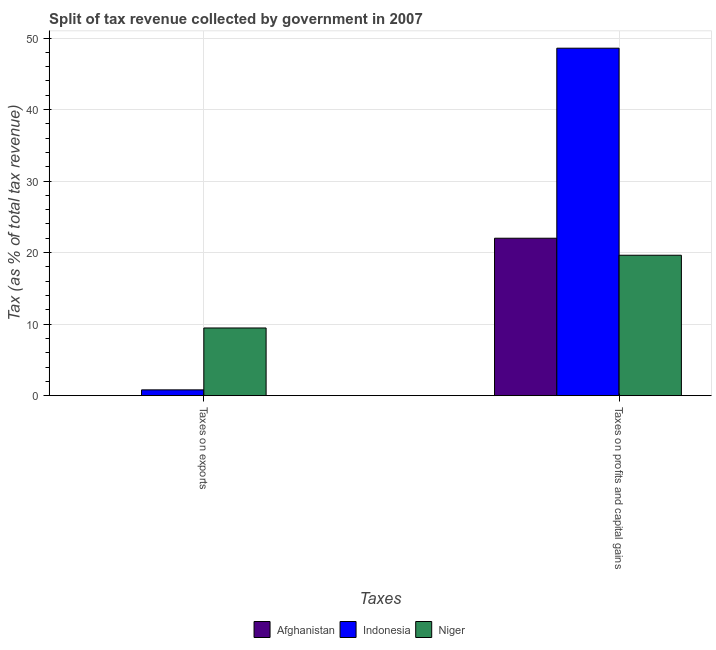Are the number of bars on each tick of the X-axis equal?
Keep it short and to the point. Yes. What is the label of the 2nd group of bars from the left?
Your answer should be very brief. Taxes on profits and capital gains. What is the percentage of revenue obtained from taxes on profits and capital gains in Afghanistan?
Your answer should be compact. 22.01. Across all countries, what is the maximum percentage of revenue obtained from taxes on profits and capital gains?
Provide a succinct answer. 48.58. Across all countries, what is the minimum percentage of revenue obtained from taxes on profits and capital gains?
Your response must be concise. 19.63. In which country was the percentage of revenue obtained from taxes on exports maximum?
Provide a short and direct response. Niger. In which country was the percentage of revenue obtained from taxes on profits and capital gains minimum?
Provide a succinct answer. Niger. What is the total percentage of revenue obtained from taxes on exports in the graph?
Keep it short and to the point. 10.28. What is the difference between the percentage of revenue obtained from taxes on exports in Afghanistan and that in Niger?
Offer a terse response. -9.45. What is the difference between the percentage of revenue obtained from taxes on profits and capital gains in Indonesia and the percentage of revenue obtained from taxes on exports in Niger?
Provide a short and direct response. 39.12. What is the average percentage of revenue obtained from taxes on profits and capital gains per country?
Offer a terse response. 30.07. What is the difference between the percentage of revenue obtained from taxes on profits and capital gains and percentage of revenue obtained from taxes on exports in Indonesia?
Keep it short and to the point. 47.77. In how many countries, is the percentage of revenue obtained from taxes on profits and capital gains greater than 16 %?
Provide a short and direct response. 3. What is the ratio of the percentage of revenue obtained from taxes on profits and capital gains in Indonesia to that in Afghanistan?
Provide a succinct answer. 2.21. Is the percentage of revenue obtained from taxes on profits and capital gains in Niger less than that in Indonesia?
Make the answer very short. Yes. In how many countries, is the percentage of revenue obtained from taxes on exports greater than the average percentage of revenue obtained from taxes on exports taken over all countries?
Provide a short and direct response. 1. What does the 2nd bar from the left in Taxes on profits and capital gains represents?
Your answer should be very brief. Indonesia. What does the 3rd bar from the right in Taxes on exports represents?
Make the answer very short. Afghanistan. What is the difference between two consecutive major ticks on the Y-axis?
Ensure brevity in your answer.  10. Are the values on the major ticks of Y-axis written in scientific E-notation?
Your response must be concise. No. Where does the legend appear in the graph?
Ensure brevity in your answer.  Bottom center. How are the legend labels stacked?
Your answer should be very brief. Horizontal. What is the title of the graph?
Give a very brief answer. Split of tax revenue collected by government in 2007. Does "Swaziland" appear as one of the legend labels in the graph?
Your response must be concise. No. What is the label or title of the X-axis?
Provide a short and direct response. Taxes. What is the label or title of the Y-axis?
Your answer should be very brief. Tax (as % of total tax revenue). What is the Tax (as % of total tax revenue) in Afghanistan in Taxes on exports?
Offer a very short reply. 0.01. What is the Tax (as % of total tax revenue) in Indonesia in Taxes on exports?
Provide a succinct answer. 0.81. What is the Tax (as % of total tax revenue) of Niger in Taxes on exports?
Provide a short and direct response. 9.46. What is the Tax (as % of total tax revenue) of Afghanistan in Taxes on profits and capital gains?
Provide a succinct answer. 22.01. What is the Tax (as % of total tax revenue) of Indonesia in Taxes on profits and capital gains?
Your answer should be compact. 48.58. What is the Tax (as % of total tax revenue) of Niger in Taxes on profits and capital gains?
Offer a very short reply. 19.63. Across all Taxes, what is the maximum Tax (as % of total tax revenue) in Afghanistan?
Give a very brief answer. 22.01. Across all Taxes, what is the maximum Tax (as % of total tax revenue) in Indonesia?
Make the answer very short. 48.58. Across all Taxes, what is the maximum Tax (as % of total tax revenue) in Niger?
Keep it short and to the point. 19.63. Across all Taxes, what is the minimum Tax (as % of total tax revenue) of Afghanistan?
Your answer should be compact. 0.01. Across all Taxes, what is the minimum Tax (as % of total tax revenue) of Indonesia?
Make the answer very short. 0.81. Across all Taxes, what is the minimum Tax (as % of total tax revenue) of Niger?
Your answer should be compact. 9.46. What is the total Tax (as % of total tax revenue) in Afghanistan in the graph?
Keep it short and to the point. 22.02. What is the total Tax (as % of total tax revenue) in Indonesia in the graph?
Make the answer very short. 49.39. What is the total Tax (as % of total tax revenue) in Niger in the graph?
Make the answer very short. 29.09. What is the difference between the Tax (as % of total tax revenue) of Afghanistan in Taxes on exports and that in Taxes on profits and capital gains?
Provide a succinct answer. -22. What is the difference between the Tax (as % of total tax revenue) in Indonesia in Taxes on exports and that in Taxes on profits and capital gains?
Offer a terse response. -47.77. What is the difference between the Tax (as % of total tax revenue) in Niger in Taxes on exports and that in Taxes on profits and capital gains?
Your answer should be compact. -10.17. What is the difference between the Tax (as % of total tax revenue) of Afghanistan in Taxes on exports and the Tax (as % of total tax revenue) of Indonesia in Taxes on profits and capital gains?
Make the answer very short. -48.56. What is the difference between the Tax (as % of total tax revenue) of Afghanistan in Taxes on exports and the Tax (as % of total tax revenue) of Niger in Taxes on profits and capital gains?
Your answer should be compact. -19.62. What is the difference between the Tax (as % of total tax revenue) of Indonesia in Taxes on exports and the Tax (as % of total tax revenue) of Niger in Taxes on profits and capital gains?
Offer a terse response. -18.82. What is the average Tax (as % of total tax revenue) in Afghanistan per Taxes?
Ensure brevity in your answer.  11.01. What is the average Tax (as % of total tax revenue) in Indonesia per Taxes?
Offer a very short reply. 24.69. What is the average Tax (as % of total tax revenue) of Niger per Taxes?
Offer a very short reply. 14.55. What is the difference between the Tax (as % of total tax revenue) of Afghanistan and Tax (as % of total tax revenue) of Indonesia in Taxes on exports?
Make the answer very short. -0.79. What is the difference between the Tax (as % of total tax revenue) in Afghanistan and Tax (as % of total tax revenue) in Niger in Taxes on exports?
Your response must be concise. -9.45. What is the difference between the Tax (as % of total tax revenue) of Indonesia and Tax (as % of total tax revenue) of Niger in Taxes on exports?
Give a very brief answer. -8.66. What is the difference between the Tax (as % of total tax revenue) in Afghanistan and Tax (as % of total tax revenue) in Indonesia in Taxes on profits and capital gains?
Offer a very short reply. -26.57. What is the difference between the Tax (as % of total tax revenue) in Afghanistan and Tax (as % of total tax revenue) in Niger in Taxes on profits and capital gains?
Make the answer very short. 2.38. What is the difference between the Tax (as % of total tax revenue) in Indonesia and Tax (as % of total tax revenue) in Niger in Taxes on profits and capital gains?
Offer a terse response. 28.95. What is the ratio of the Tax (as % of total tax revenue) in Afghanistan in Taxes on exports to that in Taxes on profits and capital gains?
Your answer should be compact. 0. What is the ratio of the Tax (as % of total tax revenue) of Indonesia in Taxes on exports to that in Taxes on profits and capital gains?
Give a very brief answer. 0.02. What is the ratio of the Tax (as % of total tax revenue) in Niger in Taxes on exports to that in Taxes on profits and capital gains?
Offer a terse response. 0.48. What is the difference between the highest and the second highest Tax (as % of total tax revenue) in Afghanistan?
Make the answer very short. 22. What is the difference between the highest and the second highest Tax (as % of total tax revenue) in Indonesia?
Your response must be concise. 47.77. What is the difference between the highest and the second highest Tax (as % of total tax revenue) of Niger?
Provide a succinct answer. 10.17. What is the difference between the highest and the lowest Tax (as % of total tax revenue) in Afghanistan?
Your response must be concise. 22. What is the difference between the highest and the lowest Tax (as % of total tax revenue) of Indonesia?
Ensure brevity in your answer.  47.77. What is the difference between the highest and the lowest Tax (as % of total tax revenue) in Niger?
Provide a short and direct response. 10.17. 